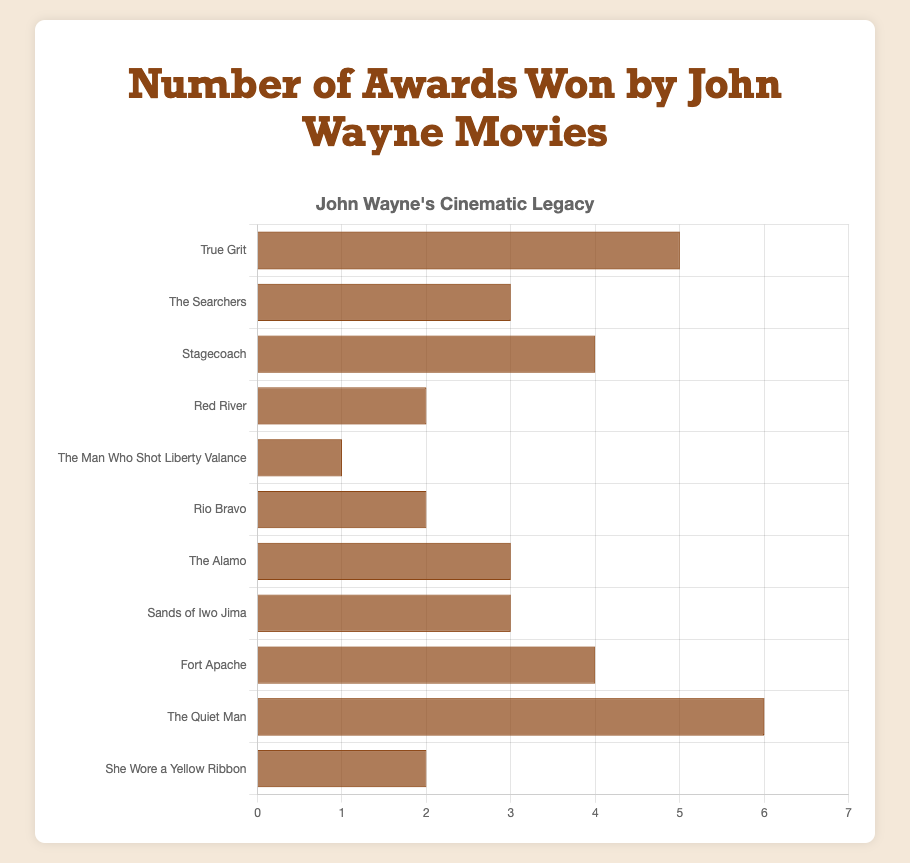Which movie won the most awards? "The Quiet Man" has the tallest bar in the chart, indicating it won the most awards.
Answer: The Quiet Man How many awards did "True Grit" and "Stagecoach" win combined? "True Grit" won 5 awards and "Stagecoach" won 4 awards, so combined they won 5 + 4 = 9 awards.
Answer: 9 Which movie won fewer awards: "Red River" or "Rio Bravo"? Both "Red River" and "Rio Bravo" have bars of equal length, each indicating 2 awards.
Answer: Neither, both won equal awards What is the average number of awards won by "The Searchers", "The Alamo", and "Sands of Iwo Jima"? The number of awards won by "The Searchers" is 3, "The Alamo" is 3, and "Sands of Iwo Jima" is 3. The average is (3 + 3 + 3) / 3 = 3.
Answer: 3 Which movie's bar is exactly half the height of "The Quiet Man"'s bar? "The Quiet Man" won 6 awards. A bar that is half this height would represent 3 awards. "The Searchers", "The Alamo", and "Sands of Iwo Jima" all have bars of this height.
Answer: The Searchers, The Alamo, Sands of Iwo Jima How many more awards did "Fort Apache" win compared to "The Man Who Shot Liberty Valance"? "Fort Apache" won 4 awards, and "The Man Who Shot Liberty Valance" won 1 award. The difference is 4 - 1 = 3 awards.
Answer: 3 What is the total number of awards won by all the movies listed? Summing up all the awards: 5 (True Grit) + 3 (The Searchers) + 4 (Stagecoach) + 2 (Red River) + 1 (The Man Who Shot Liberty Valance) + 2 (Rio Bravo) + 3 (The Alamo) + 3 (Sands of Iwo Jima) + 4 (Fort Apache) + 6 (The Quiet Man) + 2 (She Wore a Yellow Ribbon) = 35 awards.
Answer: 35 How many movies won exactly 2 awards? "Red River", "Rio Bravo", and "She Wore a Yellow Ribbon" each have bars representing exactly 2 awards.
Answer: 3 Which movies won more awards than "True Grit"? "True Grit" won 5 awards. "The Quiet Man", which won 6 awards, has a taller bar.
Answer: The Quiet Man Which movie has a bar that is exactly twice the height of "The Man Who Shot Liberty Valance"'s bar? "The Man Who Shot Liberty Valance" won 1 award. A bar that is twice this height would represent 2 awards. "Red River", "Rio Bravo", and "She Wore a Yellow Ribbon" each have bars of this height.
Answer: Red River, Rio Bravo, She Wore a Yellow Ribbon 